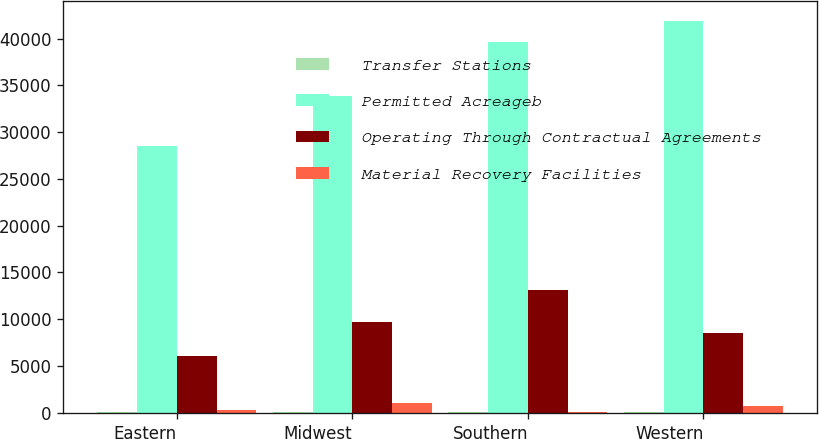<chart> <loc_0><loc_0><loc_500><loc_500><stacked_bar_chart><ecel><fcel>Eastern<fcel>Midwest<fcel>Southern<fcel>Western<nl><fcel>Transfer Stations<fcel>37<fcel>74<fcel>80<fcel>41<nl><fcel>Permitted Acreageb<fcel>28509<fcel>33829<fcel>39622<fcel>41870<nl><fcel>Operating Through Contractual Agreements<fcel>6047<fcel>9692<fcel>13078<fcel>8531<nl><fcel>Material Recovery Facilities<fcel>345<fcel>1102<fcel>136<fcel>725<nl></chart> 